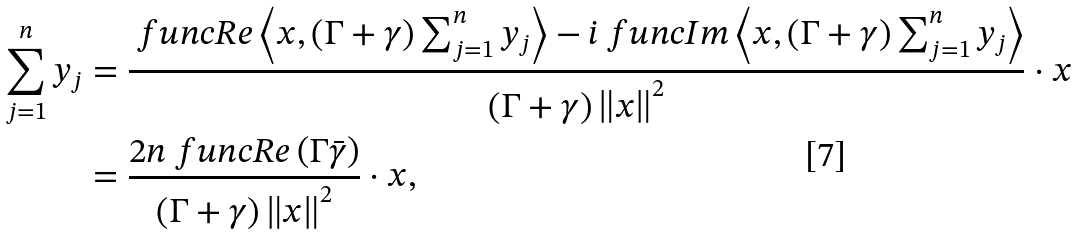<formula> <loc_0><loc_0><loc_500><loc_500>\sum _ { j = 1 } ^ { n } y _ { j } & = \frac { \ f u n c { R e } \left \langle x , \left ( \Gamma + \gamma \right ) \sum _ { j = 1 } ^ { n } y _ { j } \right \rangle - i \ f u n c { I m } \left \langle x , \left ( \Gamma + \gamma \right ) \sum _ { j = 1 } ^ { n } y _ { j } \right \rangle } { \left ( \Gamma + \gamma \right ) \left \| x \right \| ^ { 2 } } \cdot x \\ & = \frac { 2 n \ f u n c { R e } \left ( \Gamma \bar { \gamma } \right ) } { \left ( \Gamma + \gamma \right ) \left \| x \right \| ^ { 2 } } \cdot x ,</formula> 